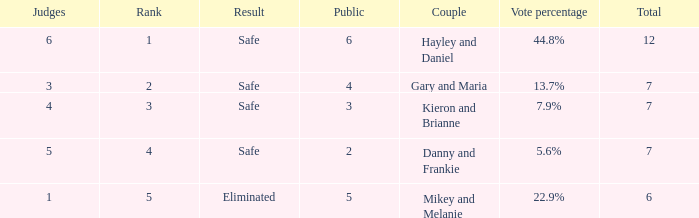How many judges were there for the eliminated couple?  1.0. 